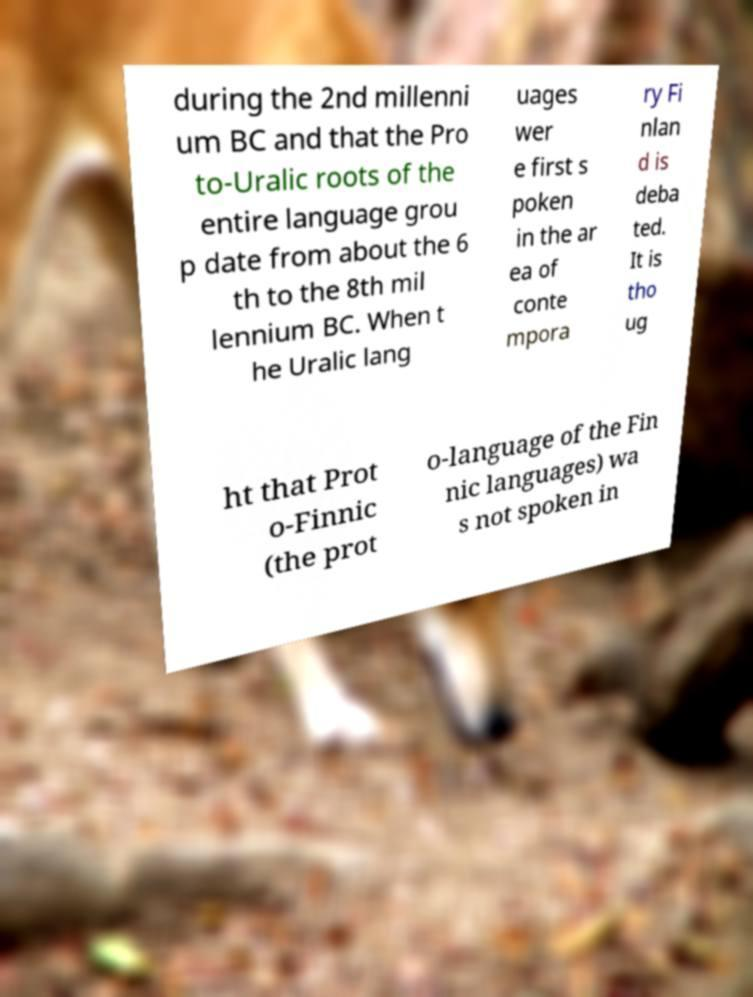Please read and relay the text visible in this image. What does it say? during the 2nd millenni um BC and that the Pro to-Uralic roots of the entire language grou p date from about the 6 th to the 8th mil lennium BC. When t he Uralic lang uages wer e first s poken in the ar ea of conte mpora ry Fi nlan d is deba ted. It is tho ug ht that Prot o-Finnic (the prot o-language of the Fin nic languages) wa s not spoken in 